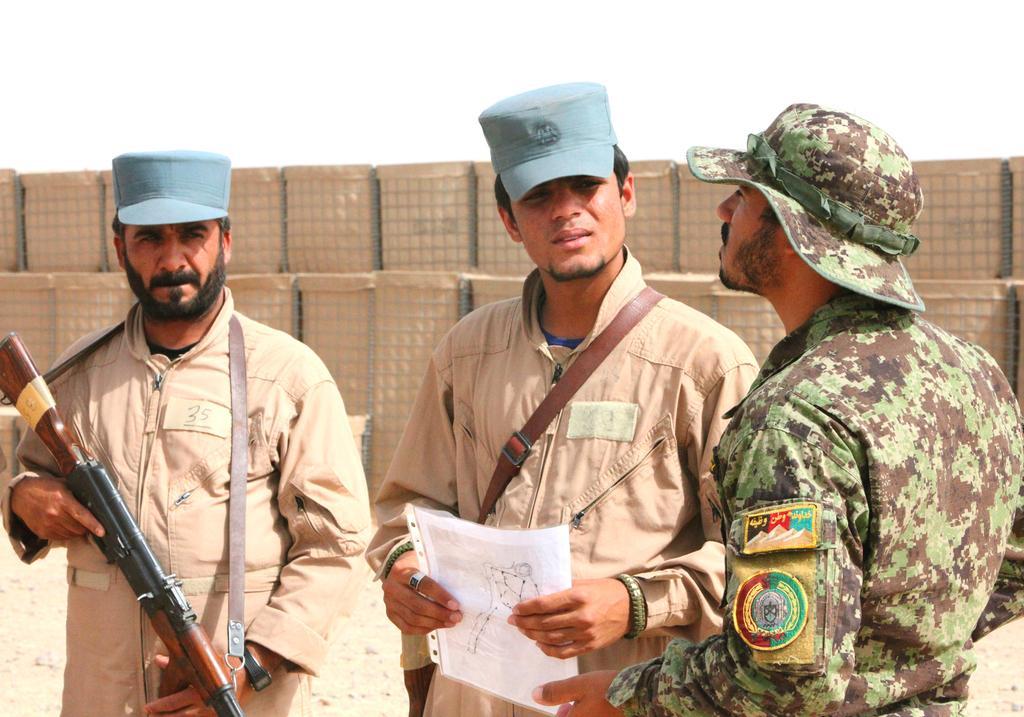How would you summarize this image in a sentence or two? In this image we can see persons standing and one of them is holding gun in the hands. In the background we can see cardboard cartons and sky. 